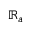Convert formula to latex. <formula><loc_0><loc_0><loc_500><loc_500>\mathbb { R } _ { a }</formula> 